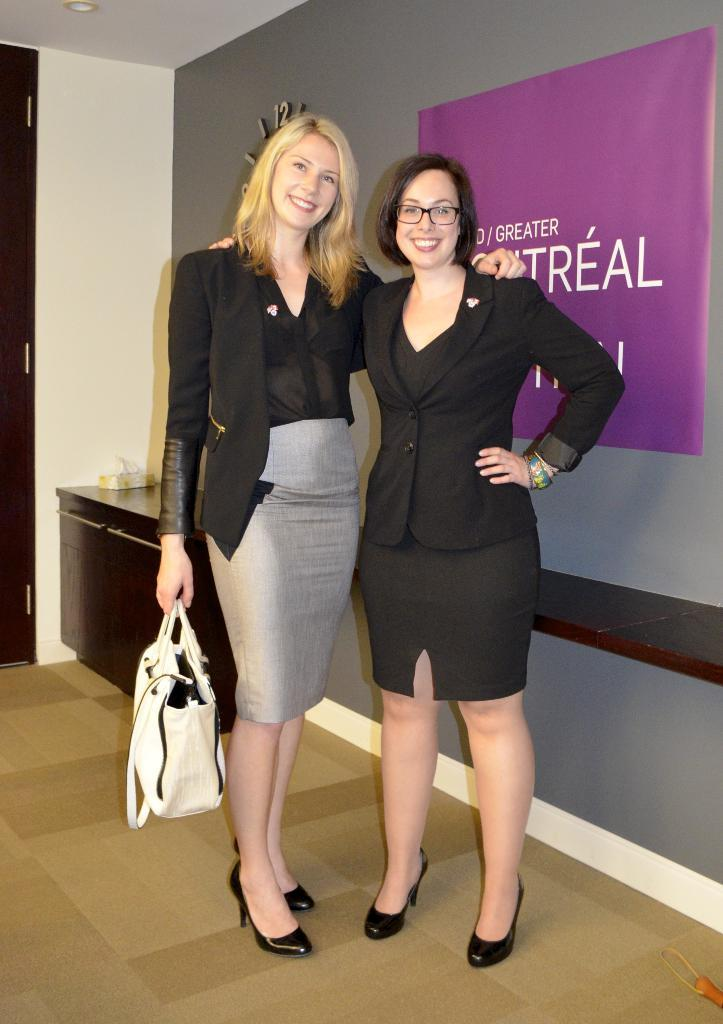How many people are in the image? There are two women in the image. What are the women doing in the image? The women are standing on a path. What is behind the women in the image? There is a wall behind the women. What color is the dress the cat is wearing in the image? There is no cat present in the image, and therefore no dress or color to describe. 